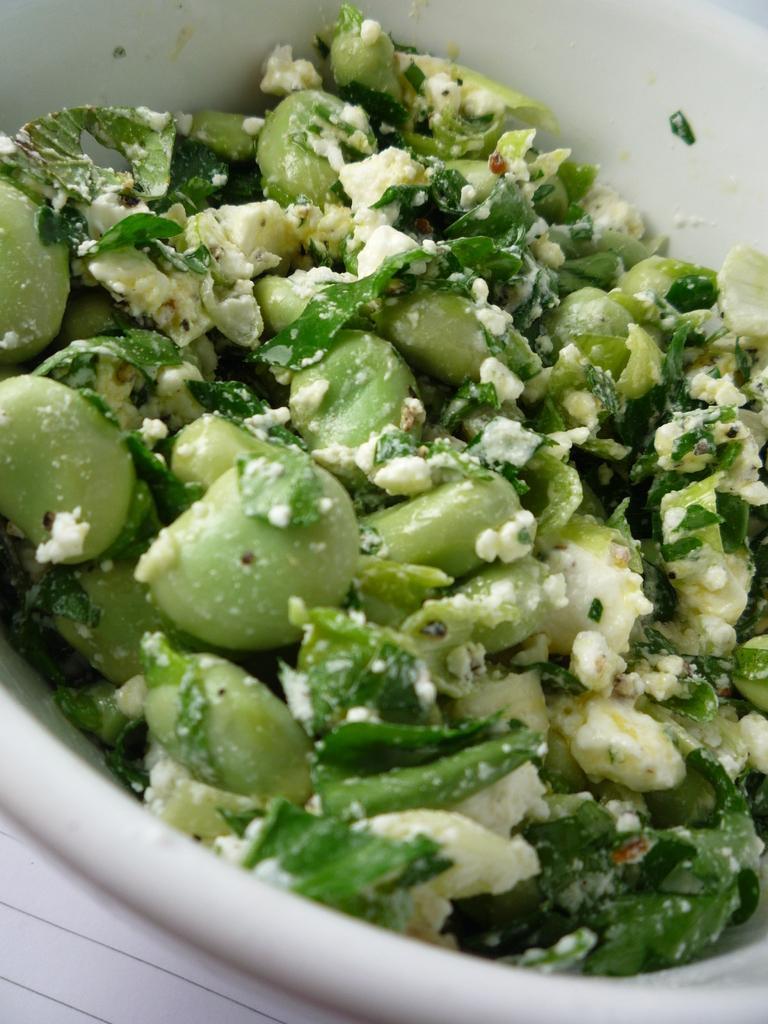Please provide a concise description of this image. In the image there some cooked green vegetable food item is kept in a bowl. 